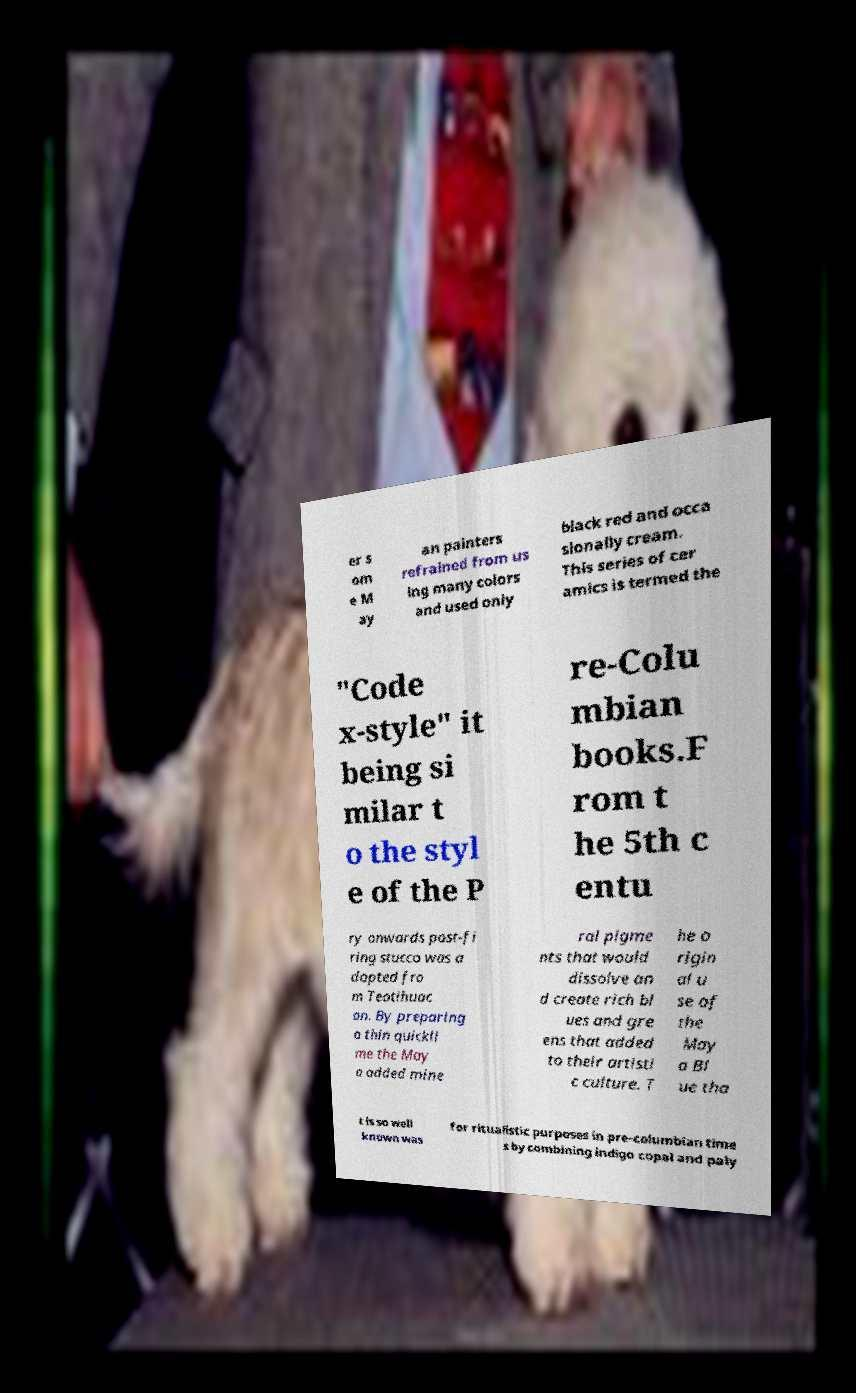Please read and relay the text visible in this image. What does it say? er s om e M ay an painters refrained from us ing many colors and used only black red and occa sionally cream. This series of cer amics is termed the "Code x-style" it being si milar t o the styl e of the P re-Colu mbian books.F rom t he 5th c entu ry onwards post-fi ring stucco was a dopted fro m Teotihuac an. By preparing a thin quickli me the May a added mine ral pigme nts that would dissolve an d create rich bl ues and gre ens that added to their artisti c culture. T he o rigin al u se of the May a Bl ue tha t is so well known was for ritualistic purposes in pre-columbian time s by combining indigo copal and paly 